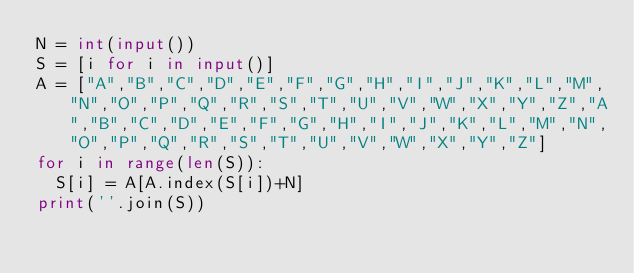Convert code to text. <code><loc_0><loc_0><loc_500><loc_500><_Python_>N = int(input())
S = [i for i in input()]
A = ["A","B","C","D","E","F","G","H","I","J","K","L","M","N","O","P","Q","R","S","T","U","V","W","X","Y","Z","A","B","C","D","E","F","G","H","I","J","K","L","M","N","O","P","Q","R","S","T","U","V","W","X","Y","Z"]
for i in range(len(S)):
  S[i] = A[A.index(S[i])+N]
print(''.join(S))</code> 